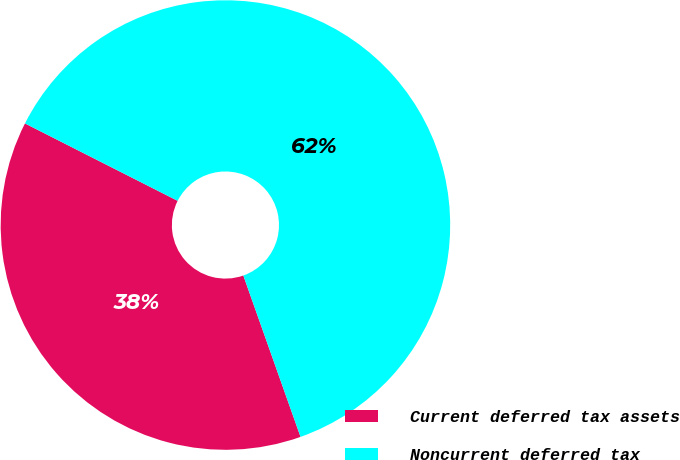Convert chart to OTSL. <chart><loc_0><loc_0><loc_500><loc_500><pie_chart><fcel>Current deferred tax assets<fcel>Noncurrent deferred tax<nl><fcel>37.89%<fcel>62.11%<nl></chart> 